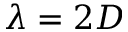<formula> <loc_0><loc_0><loc_500><loc_500>\lambda = 2 D</formula> 